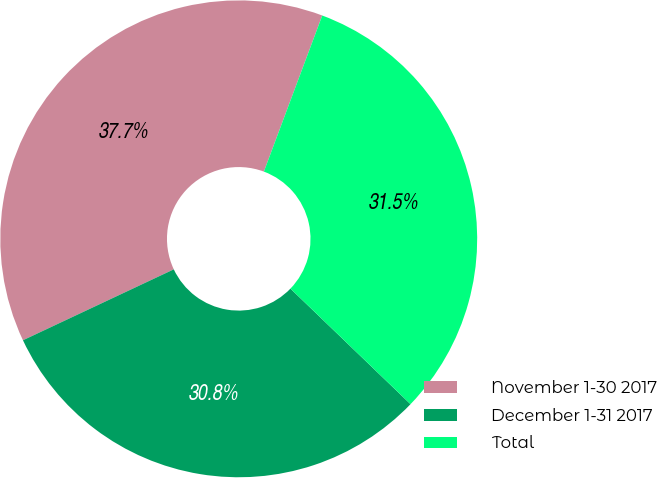Convert chart. <chart><loc_0><loc_0><loc_500><loc_500><pie_chart><fcel>November 1-30 2017<fcel>December 1-31 2017<fcel>Total<nl><fcel>37.69%<fcel>30.81%<fcel>31.5%<nl></chart> 